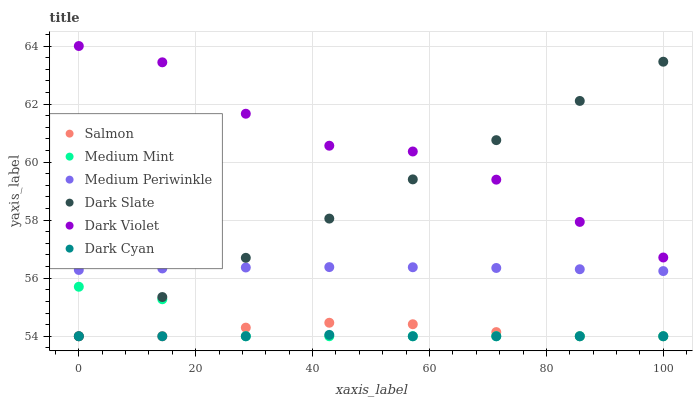Does Dark Cyan have the minimum area under the curve?
Answer yes or no. Yes. Does Dark Violet have the maximum area under the curve?
Answer yes or no. Yes. Does Salmon have the minimum area under the curve?
Answer yes or no. No. Does Salmon have the maximum area under the curve?
Answer yes or no. No. Is Dark Slate the smoothest?
Answer yes or no. Yes. Is Dark Violet the roughest?
Answer yes or no. Yes. Is Salmon the smoothest?
Answer yes or no. No. Is Salmon the roughest?
Answer yes or no. No. Does Medium Mint have the lowest value?
Answer yes or no. Yes. Does Medium Periwinkle have the lowest value?
Answer yes or no. No. Does Dark Violet have the highest value?
Answer yes or no. Yes. Does Salmon have the highest value?
Answer yes or no. No. Is Medium Mint less than Medium Periwinkle?
Answer yes or no. Yes. Is Dark Violet greater than Salmon?
Answer yes or no. Yes. Does Dark Slate intersect Salmon?
Answer yes or no. Yes. Is Dark Slate less than Salmon?
Answer yes or no. No. Is Dark Slate greater than Salmon?
Answer yes or no. No. Does Medium Mint intersect Medium Periwinkle?
Answer yes or no. No. 